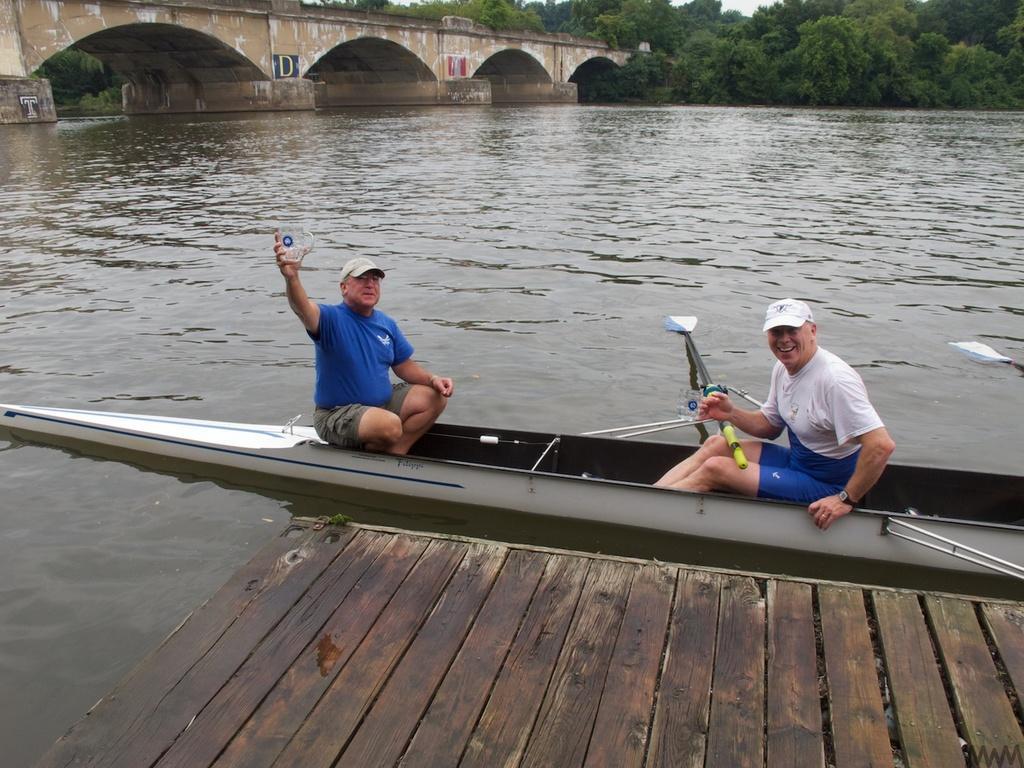Can you describe this image briefly? In this image we can see few people sitting on the watercraft. We can see the lake in the image. There are many trees in the image. We can see the sky in the image. There is a bridge in the image. 